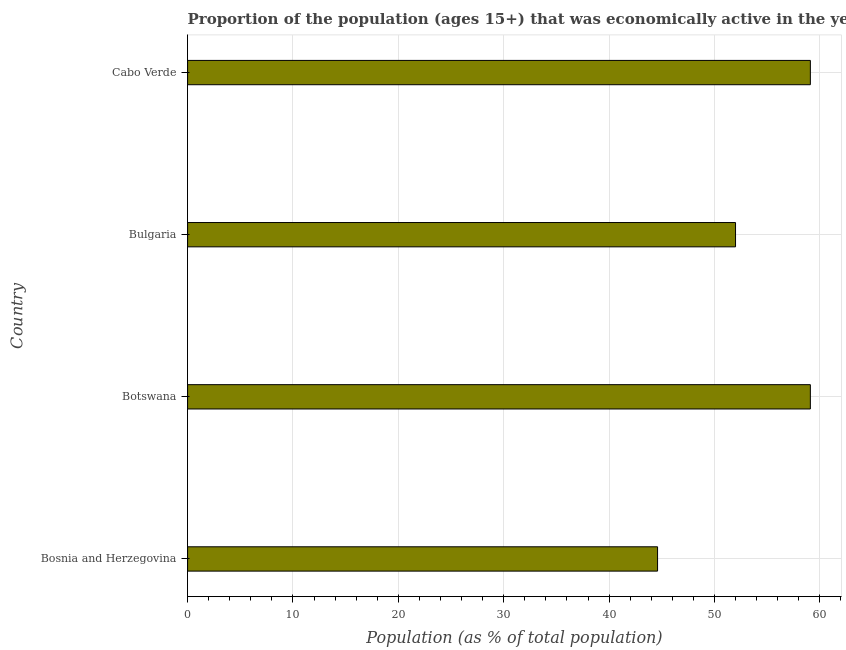What is the title of the graph?
Provide a short and direct response. Proportion of the population (ages 15+) that was economically active in the year 2010. What is the label or title of the X-axis?
Your response must be concise. Population (as % of total population). What is the label or title of the Y-axis?
Give a very brief answer. Country. What is the percentage of economically active population in Cabo Verde?
Make the answer very short. 59.1. Across all countries, what is the maximum percentage of economically active population?
Keep it short and to the point. 59.1. Across all countries, what is the minimum percentage of economically active population?
Offer a very short reply. 44.6. In which country was the percentage of economically active population maximum?
Keep it short and to the point. Botswana. In which country was the percentage of economically active population minimum?
Your answer should be compact. Bosnia and Herzegovina. What is the sum of the percentage of economically active population?
Offer a terse response. 214.8. What is the average percentage of economically active population per country?
Offer a terse response. 53.7. What is the median percentage of economically active population?
Your answer should be very brief. 55.55. In how many countries, is the percentage of economically active population greater than 46 %?
Your response must be concise. 3. What is the ratio of the percentage of economically active population in Bosnia and Herzegovina to that in Cabo Verde?
Provide a succinct answer. 0.76. What is the difference between the highest and the second highest percentage of economically active population?
Give a very brief answer. 0. In how many countries, is the percentage of economically active population greater than the average percentage of economically active population taken over all countries?
Provide a succinct answer. 2. How many bars are there?
Your answer should be compact. 4. Are all the bars in the graph horizontal?
Ensure brevity in your answer.  Yes. What is the Population (as % of total population) of Bosnia and Herzegovina?
Offer a very short reply. 44.6. What is the Population (as % of total population) of Botswana?
Your answer should be compact. 59.1. What is the Population (as % of total population) of Bulgaria?
Ensure brevity in your answer.  52. What is the Population (as % of total population) in Cabo Verde?
Your answer should be compact. 59.1. What is the difference between the Population (as % of total population) in Bosnia and Herzegovina and Botswana?
Provide a short and direct response. -14.5. What is the difference between the Population (as % of total population) in Bosnia and Herzegovina and Bulgaria?
Ensure brevity in your answer.  -7.4. What is the difference between the Population (as % of total population) in Botswana and Cabo Verde?
Provide a succinct answer. 0. What is the ratio of the Population (as % of total population) in Bosnia and Herzegovina to that in Botswana?
Your answer should be very brief. 0.76. What is the ratio of the Population (as % of total population) in Bosnia and Herzegovina to that in Bulgaria?
Your answer should be very brief. 0.86. What is the ratio of the Population (as % of total population) in Bosnia and Herzegovina to that in Cabo Verde?
Provide a short and direct response. 0.76. What is the ratio of the Population (as % of total population) in Botswana to that in Bulgaria?
Give a very brief answer. 1.14. What is the ratio of the Population (as % of total population) in Bulgaria to that in Cabo Verde?
Ensure brevity in your answer.  0.88. 